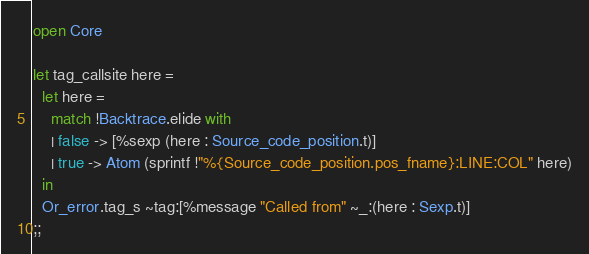<code> <loc_0><loc_0><loc_500><loc_500><_OCaml_>open Core

let tag_callsite here =
  let here =
    match !Backtrace.elide with
    | false -> [%sexp (here : Source_code_position.t)]
    | true -> Atom (sprintf !"%{Source_code_position.pos_fname}:LINE:COL" here)
  in
  Or_error.tag_s ~tag:[%message "Called from" ~_:(here : Sexp.t)]
;;
</code> 